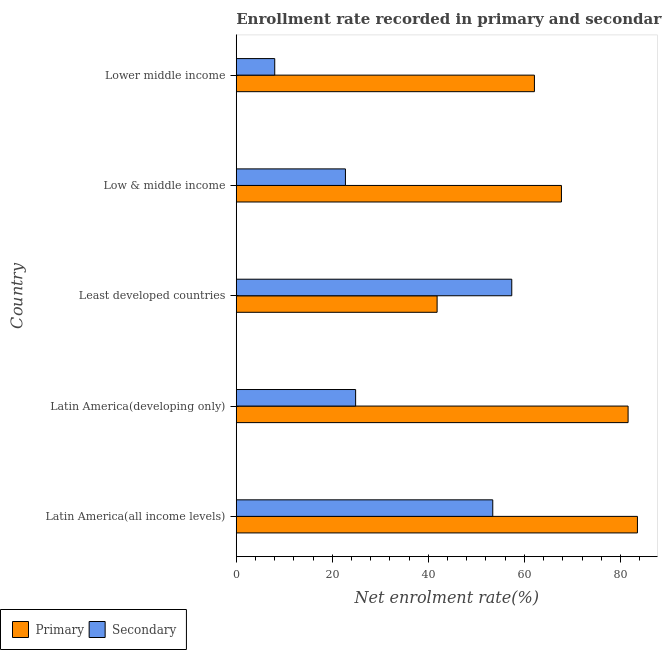How many different coloured bars are there?
Offer a very short reply. 2. How many groups of bars are there?
Your answer should be very brief. 5. What is the label of the 1st group of bars from the top?
Your response must be concise. Lower middle income. In how many cases, is the number of bars for a given country not equal to the number of legend labels?
Make the answer very short. 0. What is the enrollment rate in secondary education in Low & middle income?
Keep it short and to the point. 22.74. Across all countries, what is the maximum enrollment rate in secondary education?
Offer a very short reply. 57.37. Across all countries, what is the minimum enrollment rate in primary education?
Give a very brief answer. 41.83. In which country was the enrollment rate in primary education maximum?
Provide a succinct answer. Latin America(all income levels). In which country was the enrollment rate in secondary education minimum?
Keep it short and to the point. Lower middle income. What is the total enrollment rate in primary education in the graph?
Provide a short and direct response. 336.77. What is the difference between the enrollment rate in primary education in Least developed countries and that in Low & middle income?
Your response must be concise. -25.89. What is the difference between the enrollment rate in primary education in Least developed countries and the enrollment rate in secondary education in Latin America(all income levels)?
Your response must be concise. -11.59. What is the average enrollment rate in secondary education per country?
Ensure brevity in your answer.  33.28. What is the difference between the enrollment rate in secondary education and enrollment rate in primary education in Lower middle income?
Offer a terse response. -54.08. In how many countries, is the enrollment rate in secondary education greater than 16 %?
Your answer should be very brief. 4. What is the ratio of the enrollment rate in primary education in Latin America(all income levels) to that in Least developed countries?
Your response must be concise. 2. Is the enrollment rate in secondary education in Latin America(developing only) less than that in Least developed countries?
Give a very brief answer. Yes. Is the difference between the enrollment rate in primary education in Latin America(developing only) and Least developed countries greater than the difference between the enrollment rate in secondary education in Latin America(developing only) and Least developed countries?
Keep it short and to the point. Yes. What is the difference between the highest and the second highest enrollment rate in primary education?
Your answer should be compact. 1.94. What is the difference between the highest and the lowest enrollment rate in primary education?
Your answer should be compact. 41.71. Is the sum of the enrollment rate in secondary education in Latin America(all income levels) and Least developed countries greater than the maximum enrollment rate in primary education across all countries?
Your answer should be compact. Yes. What does the 1st bar from the top in Low & middle income represents?
Your answer should be compact. Secondary. What does the 2nd bar from the bottom in Low & middle income represents?
Offer a terse response. Secondary. How many bars are there?
Keep it short and to the point. 10. How many countries are there in the graph?
Provide a succinct answer. 5. Are the values on the major ticks of X-axis written in scientific E-notation?
Make the answer very short. No. How many legend labels are there?
Your answer should be very brief. 2. What is the title of the graph?
Offer a terse response. Enrollment rate recorded in primary and secondary education in year 1972. Does "Under-five" appear as one of the legend labels in the graph?
Offer a terse response. No. What is the label or title of the X-axis?
Your response must be concise. Net enrolment rate(%). What is the label or title of the Y-axis?
Offer a terse response. Country. What is the Net enrolment rate(%) of Primary in Latin America(all income levels)?
Your answer should be very brief. 83.54. What is the Net enrolment rate(%) of Secondary in Latin America(all income levels)?
Your answer should be very brief. 53.42. What is the Net enrolment rate(%) in Primary in Latin America(developing only)?
Provide a succinct answer. 81.6. What is the Net enrolment rate(%) in Secondary in Latin America(developing only)?
Give a very brief answer. 24.86. What is the Net enrolment rate(%) of Primary in Least developed countries?
Offer a terse response. 41.83. What is the Net enrolment rate(%) of Secondary in Least developed countries?
Offer a very short reply. 57.37. What is the Net enrolment rate(%) in Primary in Low & middle income?
Your answer should be compact. 67.72. What is the Net enrolment rate(%) in Secondary in Low & middle income?
Keep it short and to the point. 22.74. What is the Net enrolment rate(%) in Primary in Lower middle income?
Your answer should be very brief. 62.09. What is the Net enrolment rate(%) in Secondary in Lower middle income?
Offer a terse response. 8.01. Across all countries, what is the maximum Net enrolment rate(%) of Primary?
Give a very brief answer. 83.54. Across all countries, what is the maximum Net enrolment rate(%) of Secondary?
Your response must be concise. 57.37. Across all countries, what is the minimum Net enrolment rate(%) in Primary?
Provide a succinct answer. 41.83. Across all countries, what is the minimum Net enrolment rate(%) in Secondary?
Give a very brief answer. 8.01. What is the total Net enrolment rate(%) in Primary in the graph?
Offer a terse response. 336.77. What is the total Net enrolment rate(%) in Secondary in the graph?
Ensure brevity in your answer.  166.4. What is the difference between the Net enrolment rate(%) of Primary in Latin America(all income levels) and that in Latin America(developing only)?
Keep it short and to the point. 1.94. What is the difference between the Net enrolment rate(%) of Secondary in Latin America(all income levels) and that in Latin America(developing only)?
Your answer should be compact. 28.56. What is the difference between the Net enrolment rate(%) of Primary in Latin America(all income levels) and that in Least developed countries?
Ensure brevity in your answer.  41.71. What is the difference between the Net enrolment rate(%) of Secondary in Latin America(all income levels) and that in Least developed countries?
Keep it short and to the point. -3.96. What is the difference between the Net enrolment rate(%) in Primary in Latin America(all income levels) and that in Low & middle income?
Offer a very short reply. 15.82. What is the difference between the Net enrolment rate(%) of Secondary in Latin America(all income levels) and that in Low & middle income?
Your answer should be compact. 30.68. What is the difference between the Net enrolment rate(%) of Primary in Latin America(all income levels) and that in Lower middle income?
Give a very brief answer. 21.45. What is the difference between the Net enrolment rate(%) of Secondary in Latin America(all income levels) and that in Lower middle income?
Provide a succinct answer. 45.4. What is the difference between the Net enrolment rate(%) of Primary in Latin America(developing only) and that in Least developed countries?
Keep it short and to the point. 39.77. What is the difference between the Net enrolment rate(%) in Secondary in Latin America(developing only) and that in Least developed countries?
Give a very brief answer. -32.51. What is the difference between the Net enrolment rate(%) of Primary in Latin America(developing only) and that in Low & middle income?
Your answer should be compact. 13.88. What is the difference between the Net enrolment rate(%) in Secondary in Latin America(developing only) and that in Low & middle income?
Your answer should be very brief. 2.12. What is the difference between the Net enrolment rate(%) of Primary in Latin America(developing only) and that in Lower middle income?
Provide a succinct answer. 19.51. What is the difference between the Net enrolment rate(%) in Secondary in Latin America(developing only) and that in Lower middle income?
Your answer should be compact. 16.85. What is the difference between the Net enrolment rate(%) in Primary in Least developed countries and that in Low & middle income?
Make the answer very short. -25.89. What is the difference between the Net enrolment rate(%) in Secondary in Least developed countries and that in Low & middle income?
Ensure brevity in your answer.  34.64. What is the difference between the Net enrolment rate(%) of Primary in Least developed countries and that in Lower middle income?
Provide a short and direct response. -20.26. What is the difference between the Net enrolment rate(%) in Secondary in Least developed countries and that in Lower middle income?
Your response must be concise. 49.36. What is the difference between the Net enrolment rate(%) of Primary in Low & middle income and that in Lower middle income?
Provide a succinct answer. 5.63. What is the difference between the Net enrolment rate(%) of Secondary in Low & middle income and that in Lower middle income?
Make the answer very short. 14.72. What is the difference between the Net enrolment rate(%) of Primary in Latin America(all income levels) and the Net enrolment rate(%) of Secondary in Latin America(developing only)?
Provide a short and direct response. 58.68. What is the difference between the Net enrolment rate(%) of Primary in Latin America(all income levels) and the Net enrolment rate(%) of Secondary in Least developed countries?
Make the answer very short. 26.17. What is the difference between the Net enrolment rate(%) in Primary in Latin America(all income levels) and the Net enrolment rate(%) in Secondary in Low & middle income?
Ensure brevity in your answer.  60.81. What is the difference between the Net enrolment rate(%) of Primary in Latin America(all income levels) and the Net enrolment rate(%) of Secondary in Lower middle income?
Make the answer very short. 75.53. What is the difference between the Net enrolment rate(%) in Primary in Latin America(developing only) and the Net enrolment rate(%) in Secondary in Least developed countries?
Ensure brevity in your answer.  24.22. What is the difference between the Net enrolment rate(%) in Primary in Latin America(developing only) and the Net enrolment rate(%) in Secondary in Low & middle income?
Give a very brief answer. 58.86. What is the difference between the Net enrolment rate(%) in Primary in Latin America(developing only) and the Net enrolment rate(%) in Secondary in Lower middle income?
Keep it short and to the point. 73.58. What is the difference between the Net enrolment rate(%) in Primary in Least developed countries and the Net enrolment rate(%) in Secondary in Low & middle income?
Keep it short and to the point. 19.09. What is the difference between the Net enrolment rate(%) of Primary in Least developed countries and the Net enrolment rate(%) of Secondary in Lower middle income?
Your answer should be compact. 33.81. What is the difference between the Net enrolment rate(%) of Primary in Low & middle income and the Net enrolment rate(%) of Secondary in Lower middle income?
Your answer should be compact. 59.7. What is the average Net enrolment rate(%) of Primary per country?
Ensure brevity in your answer.  67.35. What is the average Net enrolment rate(%) in Secondary per country?
Give a very brief answer. 33.28. What is the difference between the Net enrolment rate(%) in Primary and Net enrolment rate(%) in Secondary in Latin America(all income levels)?
Offer a very short reply. 30.13. What is the difference between the Net enrolment rate(%) of Primary and Net enrolment rate(%) of Secondary in Latin America(developing only)?
Your response must be concise. 56.74. What is the difference between the Net enrolment rate(%) in Primary and Net enrolment rate(%) in Secondary in Least developed countries?
Offer a very short reply. -15.55. What is the difference between the Net enrolment rate(%) of Primary and Net enrolment rate(%) of Secondary in Low & middle income?
Give a very brief answer. 44.98. What is the difference between the Net enrolment rate(%) of Primary and Net enrolment rate(%) of Secondary in Lower middle income?
Provide a succinct answer. 54.08. What is the ratio of the Net enrolment rate(%) of Primary in Latin America(all income levels) to that in Latin America(developing only)?
Give a very brief answer. 1.02. What is the ratio of the Net enrolment rate(%) of Secondary in Latin America(all income levels) to that in Latin America(developing only)?
Provide a succinct answer. 2.15. What is the ratio of the Net enrolment rate(%) in Primary in Latin America(all income levels) to that in Least developed countries?
Your response must be concise. 2. What is the ratio of the Net enrolment rate(%) in Primary in Latin America(all income levels) to that in Low & middle income?
Give a very brief answer. 1.23. What is the ratio of the Net enrolment rate(%) in Secondary in Latin America(all income levels) to that in Low & middle income?
Give a very brief answer. 2.35. What is the ratio of the Net enrolment rate(%) of Primary in Latin America(all income levels) to that in Lower middle income?
Make the answer very short. 1.35. What is the ratio of the Net enrolment rate(%) of Secondary in Latin America(all income levels) to that in Lower middle income?
Ensure brevity in your answer.  6.67. What is the ratio of the Net enrolment rate(%) in Primary in Latin America(developing only) to that in Least developed countries?
Offer a terse response. 1.95. What is the ratio of the Net enrolment rate(%) in Secondary in Latin America(developing only) to that in Least developed countries?
Provide a short and direct response. 0.43. What is the ratio of the Net enrolment rate(%) of Primary in Latin America(developing only) to that in Low & middle income?
Your answer should be compact. 1.21. What is the ratio of the Net enrolment rate(%) in Secondary in Latin America(developing only) to that in Low & middle income?
Your answer should be very brief. 1.09. What is the ratio of the Net enrolment rate(%) of Primary in Latin America(developing only) to that in Lower middle income?
Give a very brief answer. 1.31. What is the ratio of the Net enrolment rate(%) in Secondary in Latin America(developing only) to that in Lower middle income?
Your answer should be compact. 3.1. What is the ratio of the Net enrolment rate(%) of Primary in Least developed countries to that in Low & middle income?
Provide a short and direct response. 0.62. What is the ratio of the Net enrolment rate(%) of Secondary in Least developed countries to that in Low & middle income?
Make the answer very short. 2.52. What is the ratio of the Net enrolment rate(%) in Primary in Least developed countries to that in Lower middle income?
Ensure brevity in your answer.  0.67. What is the ratio of the Net enrolment rate(%) of Secondary in Least developed countries to that in Lower middle income?
Keep it short and to the point. 7.16. What is the ratio of the Net enrolment rate(%) in Primary in Low & middle income to that in Lower middle income?
Keep it short and to the point. 1.09. What is the ratio of the Net enrolment rate(%) of Secondary in Low & middle income to that in Lower middle income?
Offer a terse response. 2.84. What is the difference between the highest and the second highest Net enrolment rate(%) in Primary?
Give a very brief answer. 1.94. What is the difference between the highest and the second highest Net enrolment rate(%) in Secondary?
Keep it short and to the point. 3.96. What is the difference between the highest and the lowest Net enrolment rate(%) of Primary?
Make the answer very short. 41.71. What is the difference between the highest and the lowest Net enrolment rate(%) of Secondary?
Your response must be concise. 49.36. 